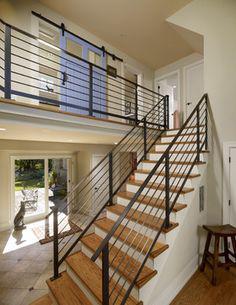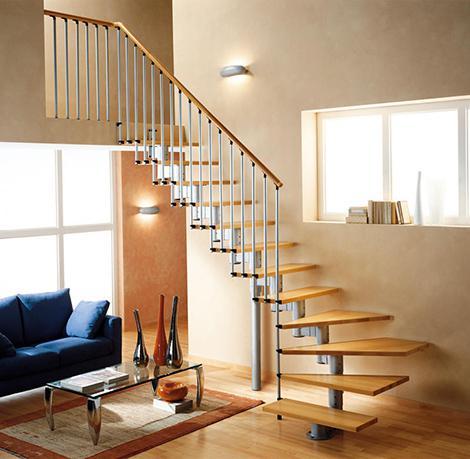The first image is the image on the left, the second image is the image on the right. For the images displayed, is the sentence "An image shows a staircase with upper landing that combines white paint with brown wood steps and features horizontal metal rails instead of vertical ones." factually correct? Answer yes or no. Yes. The first image is the image on the left, the second image is the image on the right. Evaluate the accuracy of this statement regarding the images: "One set of stairs heads in just one direction.". Is it true? Answer yes or no. Yes. 